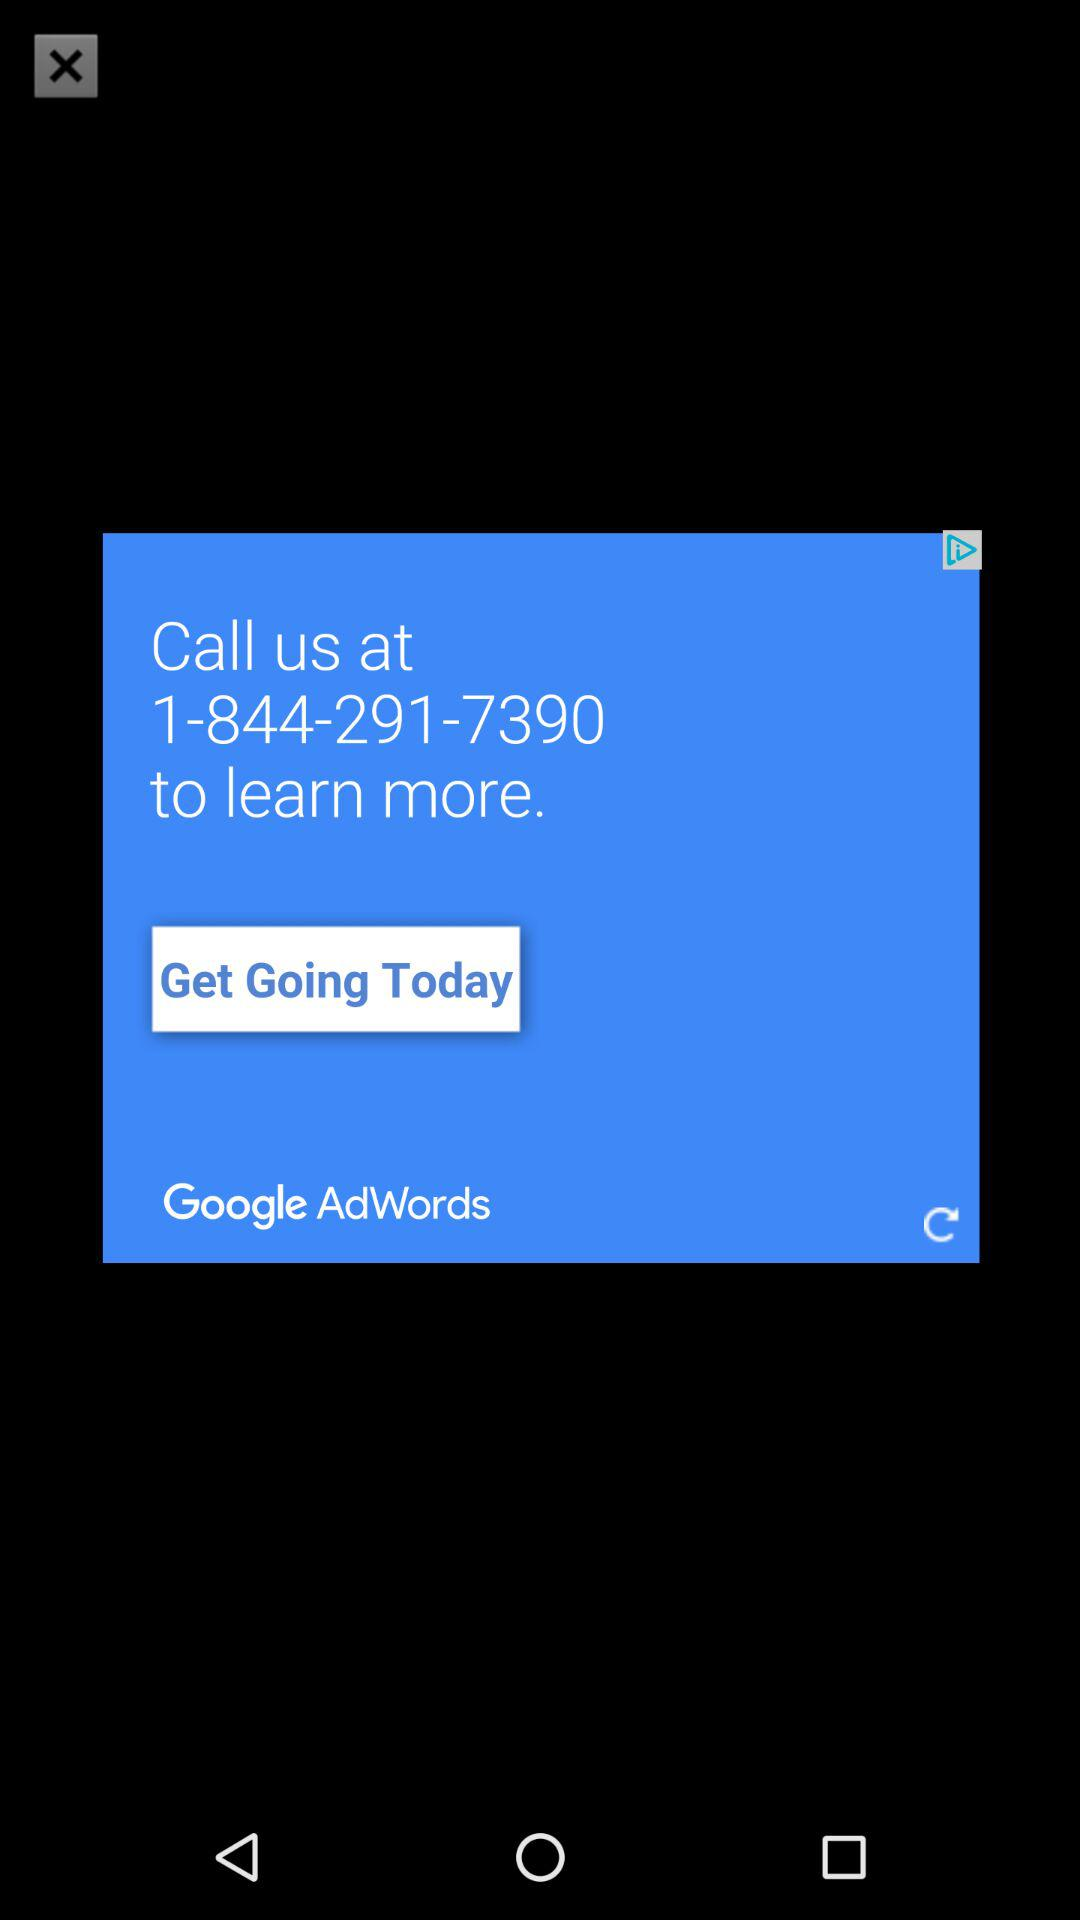What is the phone number? The phone number is 1-844-291-7390. 